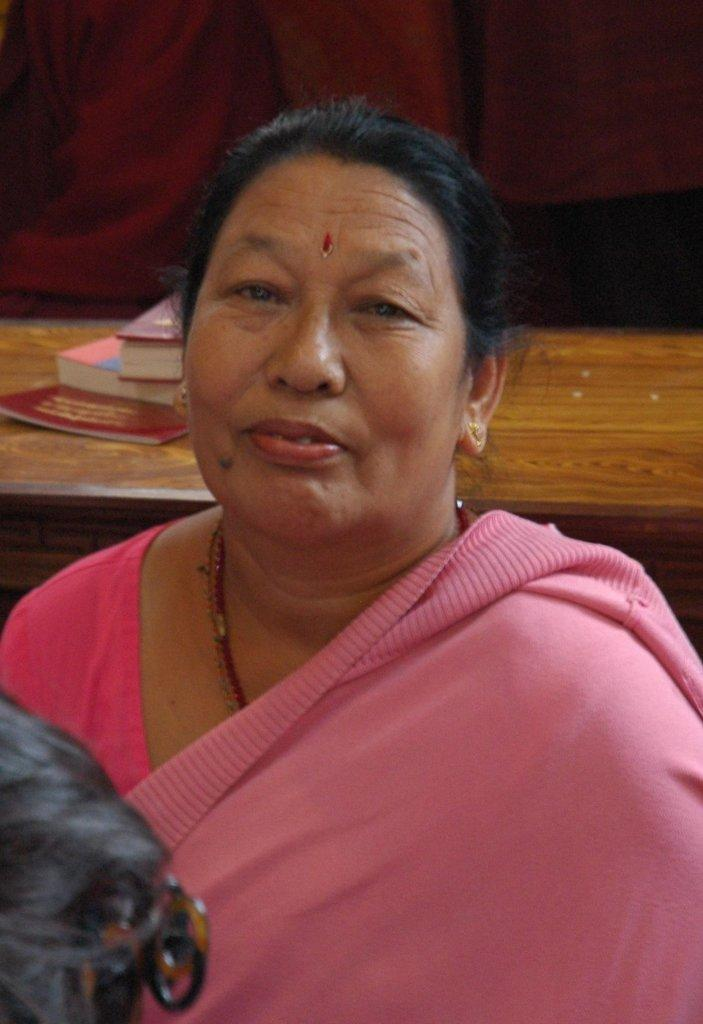Who is present in the image? There is a woman in the image. What is the woman wearing? The woman is wearing a pink saree. What can be seen in the background of the image? There is a table in the image. What is on the table? There are books on the table. What type of hook can be seen on the woman's saree in the image? There is no mention of a hook on the woman's saree. 